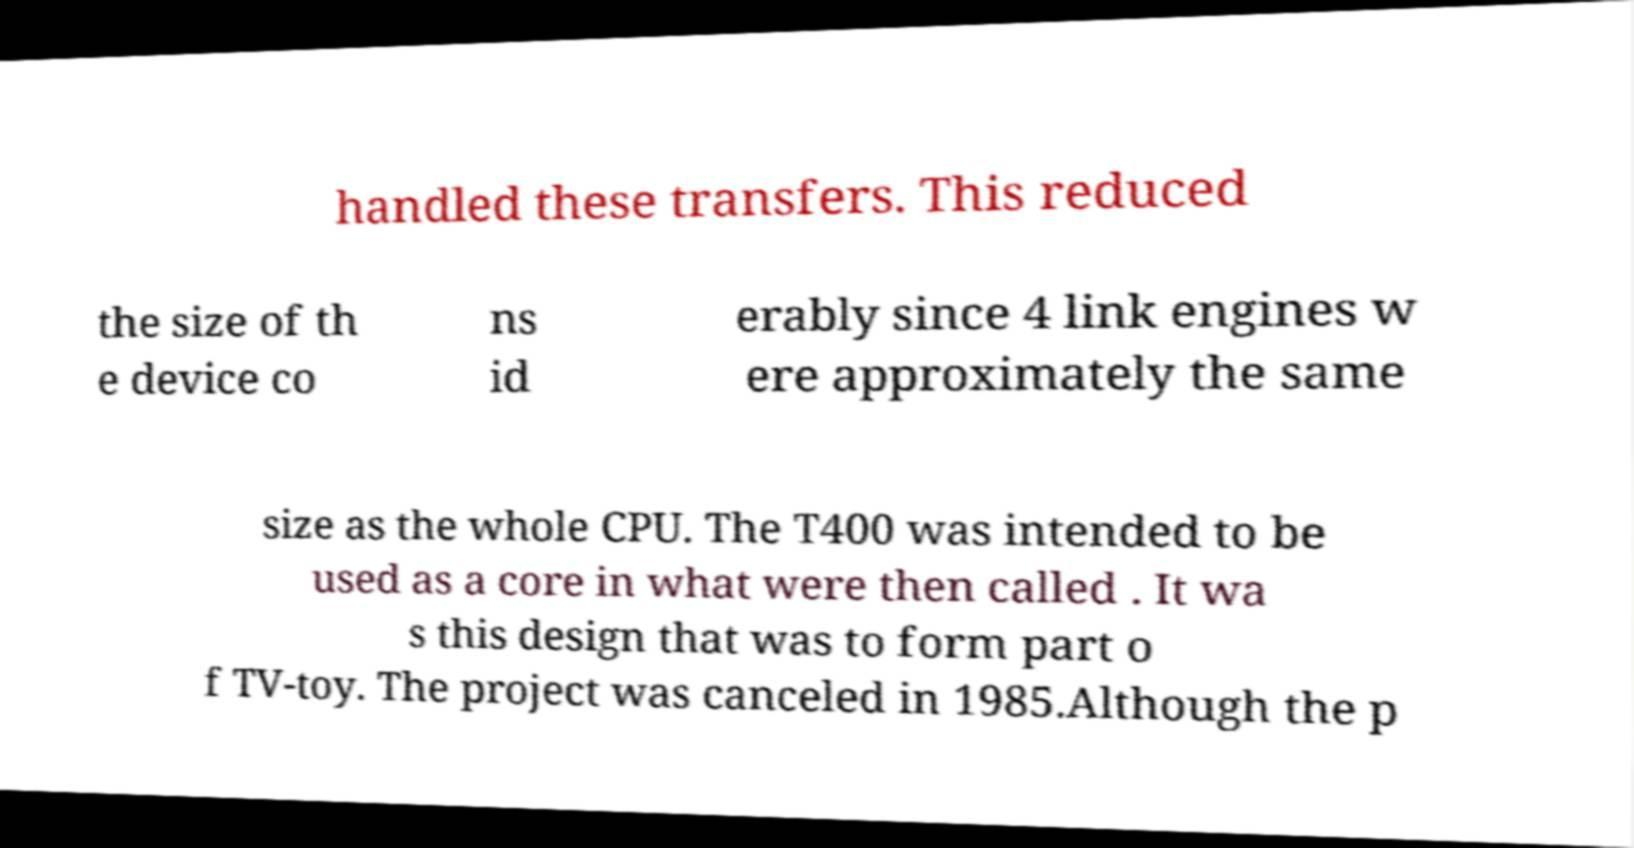Can you accurately transcribe the text from the provided image for me? handled these transfers. This reduced the size of th e device co ns id erably since 4 link engines w ere approximately the same size as the whole CPU. The T400 was intended to be used as a core in what were then called . It wa s this design that was to form part o f TV-toy. The project was canceled in 1985.Although the p 